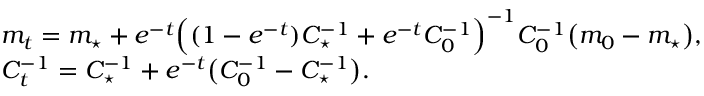<formula> <loc_0><loc_0><loc_500><loc_500>\begin{array} { r l } & { m _ { t } = m _ { ^ { * } } + e ^ { - t } \left ( ( 1 - e ^ { - t } ) C _ { ^ { * } } ^ { - 1 } + e ^ { - t } C _ { 0 } ^ { - 1 } \right ) ^ { - 1 } C _ { 0 } ^ { - 1 } \left ( m _ { 0 } - m _ { ^ { * } } \right ) , } \\ & { C _ { t } ^ { - 1 } = C _ { ^ { * } } ^ { - 1 } + e ^ { - t } \left ( C _ { 0 } ^ { - 1 } - C _ { ^ { * } } ^ { - 1 } \right ) . } \end{array}</formula> 